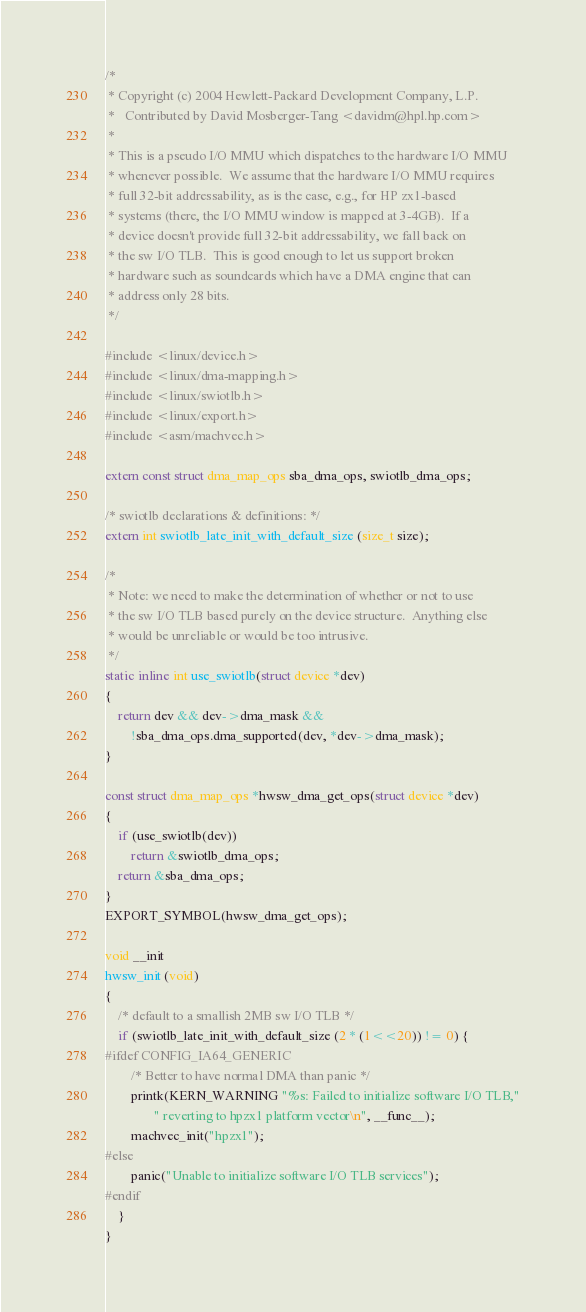<code> <loc_0><loc_0><loc_500><loc_500><_C_>/*
 * Copyright (c) 2004 Hewlett-Packard Development Company, L.P.
 *   Contributed by David Mosberger-Tang <davidm@hpl.hp.com>
 *
 * This is a pseudo I/O MMU which dispatches to the hardware I/O MMU
 * whenever possible.  We assume that the hardware I/O MMU requires
 * full 32-bit addressability, as is the case, e.g., for HP zx1-based
 * systems (there, the I/O MMU window is mapped at 3-4GB).  If a
 * device doesn't provide full 32-bit addressability, we fall back on
 * the sw I/O TLB.  This is good enough to let us support broken
 * hardware such as soundcards which have a DMA engine that can
 * address only 28 bits.
 */

#include <linux/device.h>
#include <linux/dma-mapping.h>
#include <linux/swiotlb.h>
#include <linux/export.h>
#include <asm/machvec.h>

extern const struct dma_map_ops sba_dma_ops, swiotlb_dma_ops;

/* swiotlb declarations & definitions: */
extern int swiotlb_late_init_with_default_size (size_t size);

/*
 * Note: we need to make the determination of whether or not to use
 * the sw I/O TLB based purely on the device structure.  Anything else
 * would be unreliable or would be too intrusive.
 */
static inline int use_swiotlb(struct device *dev)
{
	return dev && dev->dma_mask &&
		!sba_dma_ops.dma_supported(dev, *dev->dma_mask);
}

const struct dma_map_ops *hwsw_dma_get_ops(struct device *dev)
{
	if (use_swiotlb(dev))
		return &swiotlb_dma_ops;
	return &sba_dma_ops;
}
EXPORT_SYMBOL(hwsw_dma_get_ops);

void __init
hwsw_init (void)
{
	/* default to a smallish 2MB sw I/O TLB */
	if (swiotlb_late_init_with_default_size (2 * (1<<20)) != 0) {
#ifdef CONFIG_IA64_GENERIC
		/* Better to have normal DMA than panic */
		printk(KERN_WARNING "%s: Failed to initialize software I/O TLB,"
		       " reverting to hpzx1 platform vector\n", __func__);
		machvec_init("hpzx1");
#else
		panic("Unable to initialize software I/O TLB services");
#endif
	}
}
</code> 